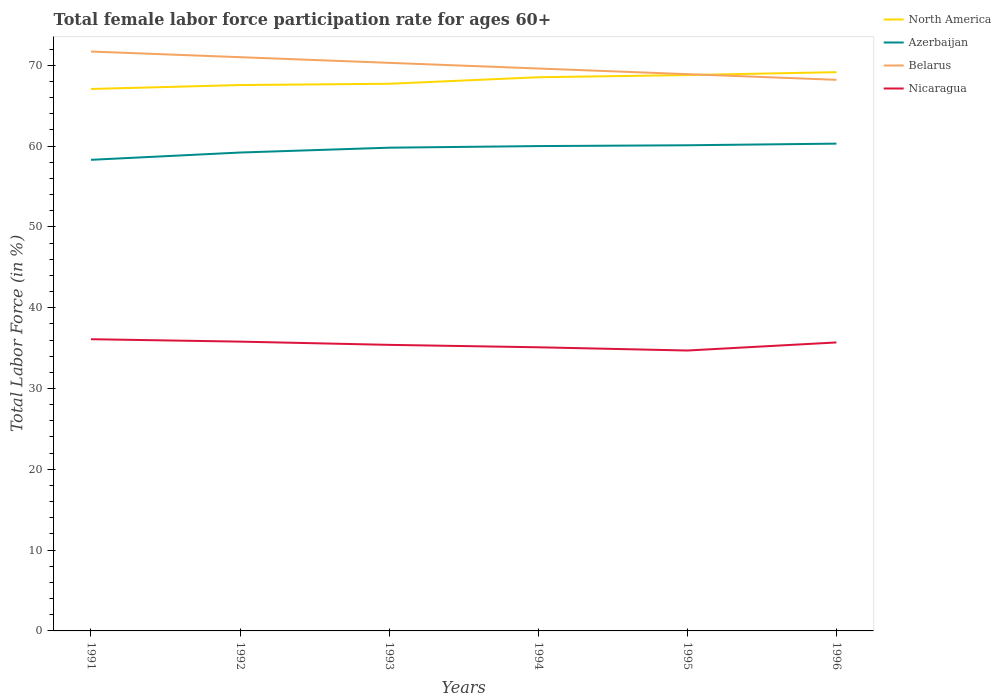How many different coloured lines are there?
Make the answer very short. 4. Does the line corresponding to North America intersect with the line corresponding to Azerbaijan?
Provide a short and direct response. No. Is the number of lines equal to the number of legend labels?
Keep it short and to the point. Yes. Across all years, what is the maximum female labor force participation rate in North America?
Keep it short and to the point. 67.06. In which year was the female labor force participation rate in North America maximum?
Your answer should be compact. 1991. What is the total female labor force participation rate in Belarus in the graph?
Your answer should be compact. 0.7. What is the difference between the highest and the second highest female labor force participation rate in Nicaragua?
Provide a short and direct response. 1.4. What is the difference between the highest and the lowest female labor force participation rate in Azerbaijan?
Your answer should be very brief. 4. How many years are there in the graph?
Give a very brief answer. 6. What is the difference between two consecutive major ticks on the Y-axis?
Provide a succinct answer. 10. Are the values on the major ticks of Y-axis written in scientific E-notation?
Offer a very short reply. No. Does the graph contain grids?
Give a very brief answer. No. What is the title of the graph?
Ensure brevity in your answer.  Total female labor force participation rate for ages 60+. What is the label or title of the X-axis?
Your answer should be compact. Years. What is the Total Labor Force (in %) in North America in 1991?
Provide a succinct answer. 67.06. What is the Total Labor Force (in %) in Azerbaijan in 1991?
Your answer should be very brief. 58.3. What is the Total Labor Force (in %) in Belarus in 1991?
Offer a very short reply. 71.7. What is the Total Labor Force (in %) in Nicaragua in 1991?
Offer a very short reply. 36.1. What is the Total Labor Force (in %) of North America in 1992?
Your answer should be compact. 67.55. What is the Total Labor Force (in %) of Azerbaijan in 1992?
Offer a very short reply. 59.2. What is the Total Labor Force (in %) in Belarus in 1992?
Offer a very short reply. 71. What is the Total Labor Force (in %) in Nicaragua in 1992?
Offer a terse response. 35.8. What is the Total Labor Force (in %) in North America in 1993?
Provide a short and direct response. 67.71. What is the Total Labor Force (in %) in Azerbaijan in 1993?
Ensure brevity in your answer.  59.8. What is the Total Labor Force (in %) of Belarus in 1993?
Provide a short and direct response. 70.3. What is the Total Labor Force (in %) in Nicaragua in 1993?
Provide a short and direct response. 35.4. What is the Total Labor Force (in %) of North America in 1994?
Keep it short and to the point. 68.52. What is the Total Labor Force (in %) of Belarus in 1994?
Provide a short and direct response. 69.6. What is the Total Labor Force (in %) of Nicaragua in 1994?
Provide a short and direct response. 35.1. What is the Total Labor Force (in %) of North America in 1995?
Provide a short and direct response. 68.79. What is the Total Labor Force (in %) of Azerbaijan in 1995?
Provide a short and direct response. 60.1. What is the Total Labor Force (in %) in Belarus in 1995?
Offer a terse response. 68.9. What is the Total Labor Force (in %) of Nicaragua in 1995?
Provide a succinct answer. 34.7. What is the Total Labor Force (in %) in North America in 1996?
Make the answer very short. 69.15. What is the Total Labor Force (in %) of Azerbaijan in 1996?
Make the answer very short. 60.3. What is the Total Labor Force (in %) of Belarus in 1996?
Offer a very short reply. 68.2. What is the Total Labor Force (in %) of Nicaragua in 1996?
Offer a terse response. 35.7. Across all years, what is the maximum Total Labor Force (in %) in North America?
Offer a terse response. 69.15. Across all years, what is the maximum Total Labor Force (in %) of Azerbaijan?
Your response must be concise. 60.3. Across all years, what is the maximum Total Labor Force (in %) in Belarus?
Keep it short and to the point. 71.7. Across all years, what is the maximum Total Labor Force (in %) in Nicaragua?
Your response must be concise. 36.1. Across all years, what is the minimum Total Labor Force (in %) of North America?
Your answer should be very brief. 67.06. Across all years, what is the minimum Total Labor Force (in %) in Azerbaijan?
Provide a short and direct response. 58.3. Across all years, what is the minimum Total Labor Force (in %) in Belarus?
Provide a succinct answer. 68.2. Across all years, what is the minimum Total Labor Force (in %) in Nicaragua?
Your response must be concise. 34.7. What is the total Total Labor Force (in %) in North America in the graph?
Your answer should be compact. 408.78. What is the total Total Labor Force (in %) of Azerbaijan in the graph?
Ensure brevity in your answer.  357.7. What is the total Total Labor Force (in %) of Belarus in the graph?
Provide a succinct answer. 419.7. What is the total Total Labor Force (in %) in Nicaragua in the graph?
Offer a very short reply. 212.8. What is the difference between the Total Labor Force (in %) of North America in 1991 and that in 1992?
Ensure brevity in your answer.  -0.49. What is the difference between the Total Labor Force (in %) in Belarus in 1991 and that in 1992?
Give a very brief answer. 0.7. What is the difference between the Total Labor Force (in %) of Nicaragua in 1991 and that in 1992?
Ensure brevity in your answer.  0.3. What is the difference between the Total Labor Force (in %) in North America in 1991 and that in 1993?
Give a very brief answer. -0.65. What is the difference between the Total Labor Force (in %) of Azerbaijan in 1991 and that in 1993?
Ensure brevity in your answer.  -1.5. What is the difference between the Total Labor Force (in %) in Belarus in 1991 and that in 1993?
Keep it short and to the point. 1.4. What is the difference between the Total Labor Force (in %) in Nicaragua in 1991 and that in 1993?
Your answer should be compact. 0.7. What is the difference between the Total Labor Force (in %) in North America in 1991 and that in 1994?
Your answer should be compact. -1.45. What is the difference between the Total Labor Force (in %) in North America in 1991 and that in 1995?
Provide a short and direct response. -1.72. What is the difference between the Total Labor Force (in %) of Belarus in 1991 and that in 1995?
Give a very brief answer. 2.8. What is the difference between the Total Labor Force (in %) in Nicaragua in 1991 and that in 1995?
Ensure brevity in your answer.  1.4. What is the difference between the Total Labor Force (in %) in North America in 1991 and that in 1996?
Make the answer very short. -2.08. What is the difference between the Total Labor Force (in %) of Azerbaijan in 1991 and that in 1996?
Keep it short and to the point. -2. What is the difference between the Total Labor Force (in %) in Belarus in 1991 and that in 1996?
Your answer should be very brief. 3.5. What is the difference between the Total Labor Force (in %) of Nicaragua in 1991 and that in 1996?
Provide a short and direct response. 0.4. What is the difference between the Total Labor Force (in %) of North America in 1992 and that in 1993?
Ensure brevity in your answer.  -0.16. What is the difference between the Total Labor Force (in %) of Azerbaijan in 1992 and that in 1993?
Give a very brief answer. -0.6. What is the difference between the Total Labor Force (in %) of Belarus in 1992 and that in 1993?
Give a very brief answer. 0.7. What is the difference between the Total Labor Force (in %) of North America in 1992 and that in 1994?
Give a very brief answer. -0.97. What is the difference between the Total Labor Force (in %) in Belarus in 1992 and that in 1994?
Provide a succinct answer. 1.4. What is the difference between the Total Labor Force (in %) in North America in 1992 and that in 1995?
Provide a succinct answer. -1.24. What is the difference between the Total Labor Force (in %) of Nicaragua in 1992 and that in 1995?
Keep it short and to the point. 1.1. What is the difference between the Total Labor Force (in %) in North America in 1992 and that in 1996?
Keep it short and to the point. -1.6. What is the difference between the Total Labor Force (in %) of North America in 1993 and that in 1994?
Offer a terse response. -0.81. What is the difference between the Total Labor Force (in %) of North America in 1993 and that in 1995?
Provide a succinct answer. -1.08. What is the difference between the Total Labor Force (in %) of Belarus in 1993 and that in 1995?
Provide a short and direct response. 1.4. What is the difference between the Total Labor Force (in %) in North America in 1993 and that in 1996?
Your response must be concise. -1.44. What is the difference between the Total Labor Force (in %) of Azerbaijan in 1993 and that in 1996?
Provide a short and direct response. -0.5. What is the difference between the Total Labor Force (in %) in North America in 1994 and that in 1995?
Make the answer very short. -0.27. What is the difference between the Total Labor Force (in %) in Azerbaijan in 1994 and that in 1995?
Your response must be concise. -0.1. What is the difference between the Total Labor Force (in %) in Nicaragua in 1994 and that in 1995?
Your answer should be compact. 0.4. What is the difference between the Total Labor Force (in %) of North America in 1994 and that in 1996?
Ensure brevity in your answer.  -0.63. What is the difference between the Total Labor Force (in %) of Belarus in 1994 and that in 1996?
Provide a short and direct response. 1.4. What is the difference between the Total Labor Force (in %) in North America in 1995 and that in 1996?
Your answer should be very brief. -0.36. What is the difference between the Total Labor Force (in %) in Nicaragua in 1995 and that in 1996?
Your response must be concise. -1. What is the difference between the Total Labor Force (in %) in North America in 1991 and the Total Labor Force (in %) in Azerbaijan in 1992?
Your response must be concise. 7.86. What is the difference between the Total Labor Force (in %) in North America in 1991 and the Total Labor Force (in %) in Belarus in 1992?
Your response must be concise. -3.94. What is the difference between the Total Labor Force (in %) of North America in 1991 and the Total Labor Force (in %) of Nicaragua in 1992?
Make the answer very short. 31.26. What is the difference between the Total Labor Force (in %) of Azerbaijan in 1991 and the Total Labor Force (in %) of Belarus in 1992?
Provide a short and direct response. -12.7. What is the difference between the Total Labor Force (in %) of Belarus in 1991 and the Total Labor Force (in %) of Nicaragua in 1992?
Make the answer very short. 35.9. What is the difference between the Total Labor Force (in %) in North America in 1991 and the Total Labor Force (in %) in Azerbaijan in 1993?
Provide a short and direct response. 7.26. What is the difference between the Total Labor Force (in %) of North America in 1991 and the Total Labor Force (in %) of Belarus in 1993?
Give a very brief answer. -3.24. What is the difference between the Total Labor Force (in %) in North America in 1991 and the Total Labor Force (in %) in Nicaragua in 1993?
Your response must be concise. 31.66. What is the difference between the Total Labor Force (in %) in Azerbaijan in 1991 and the Total Labor Force (in %) in Nicaragua in 1993?
Your response must be concise. 22.9. What is the difference between the Total Labor Force (in %) in Belarus in 1991 and the Total Labor Force (in %) in Nicaragua in 1993?
Give a very brief answer. 36.3. What is the difference between the Total Labor Force (in %) of North America in 1991 and the Total Labor Force (in %) of Azerbaijan in 1994?
Your response must be concise. 7.06. What is the difference between the Total Labor Force (in %) in North America in 1991 and the Total Labor Force (in %) in Belarus in 1994?
Offer a very short reply. -2.54. What is the difference between the Total Labor Force (in %) in North America in 1991 and the Total Labor Force (in %) in Nicaragua in 1994?
Offer a terse response. 31.96. What is the difference between the Total Labor Force (in %) of Azerbaijan in 1991 and the Total Labor Force (in %) of Belarus in 1994?
Make the answer very short. -11.3. What is the difference between the Total Labor Force (in %) of Azerbaijan in 1991 and the Total Labor Force (in %) of Nicaragua in 1994?
Make the answer very short. 23.2. What is the difference between the Total Labor Force (in %) of Belarus in 1991 and the Total Labor Force (in %) of Nicaragua in 1994?
Offer a very short reply. 36.6. What is the difference between the Total Labor Force (in %) of North America in 1991 and the Total Labor Force (in %) of Azerbaijan in 1995?
Offer a terse response. 6.96. What is the difference between the Total Labor Force (in %) of North America in 1991 and the Total Labor Force (in %) of Belarus in 1995?
Keep it short and to the point. -1.84. What is the difference between the Total Labor Force (in %) in North America in 1991 and the Total Labor Force (in %) in Nicaragua in 1995?
Give a very brief answer. 32.36. What is the difference between the Total Labor Force (in %) of Azerbaijan in 1991 and the Total Labor Force (in %) of Belarus in 1995?
Provide a short and direct response. -10.6. What is the difference between the Total Labor Force (in %) in Azerbaijan in 1991 and the Total Labor Force (in %) in Nicaragua in 1995?
Your answer should be compact. 23.6. What is the difference between the Total Labor Force (in %) in Belarus in 1991 and the Total Labor Force (in %) in Nicaragua in 1995?
Your response must be concise. 37. What is the difference between the Total Labor Force (in %) in North America in 1991 and the Total Labor Force (in %) in Azerbaijan in 1996?
Give a very brief answer. 6.76. What is the difference between the Total Labor Force (in %) in North America in 1991 and the Total Labor Force (in %) in Belarus in 1996?
Offer a very short reply. -1.14. What is the difference between the Total Labor Force (in %) in North America in 1991 and the Total Labor Force (in %) in Nicaragua in 1996?
Your answer should be very brief. 31.36. What is the difference between the Total Labor Force (in %) of Azerbaijan in 1991 and the Total Labor Force (in %) of Nicaragua in 1996?
Keep it short and to the point. 22.6. What is the difference between the Total Labor Force (in %) in Belarus in 1991 and the Total Labor Force (in %) in Nicaragua in 1996?
Offer a terse response. 36. What is the difference between the Total Labor Force (in %) in North America in 1992 and the Total Labor Force (in %) in Azerbaijan in 1993?
Your answer should be very brief. 7.75. What is the difference between the Total Labor Force (in %) in North America in 1992 and the Total Labor Force (in %) in Belarus in 1993?
Offer a very short reply. -2.75. What is the difference between the Total Labor Force (in %) of North America in 1992 and the Total Labor Force (in %) of Nicaragua in 1993?
Offer a very short reply. 32.15. What is the difference between the Total Labor Force (in %) in Azerbaijan in 1992 and the Total Labor Force (in %) in Belarus in 1993?
Provide a succinct answer. -11.1. What is the difference between the Total Labor Force (in %) of Azerbaijan in 1992 and the Total Labor Force (in %) of Nicaragua in 1993?
Offer a very short reply. 23.8. What is the difference between the Total Labor Force (in %) of Belarus in 1992 and the Total Labor Force (in %) of Nicaragua in 1993?
Offer a terse response. 35.6. What is the difference between the Total Labor Force (in %) of North America in 1992 and the Total Labor Force (in %) of Azerbaijan in 1994?
Your response must be concise. 7.55. What is the difference between the Total Labor Force (in %) in North America in 1992 and the Total Labor Force (in %) in Belarus in 1994?
Make the answer very short. -2.05. What is the difference between the Total Labor Force (in %) in North America in 1992 and the Total Labor Force (in %) in Nicaragua in 1994?
Provide a succinct answer. 32.45. What is the difference between the Total Labor Force (in %) of Azerbaijan in 1992 and the Total Labor Force (in %) of Nicaragua in 1994?
Give a very brief answer. 24.1. What is the difference between the Total Labor Force (in %) in Belarus in 1992 and the Total Labor Force (in %) in Nicaragua in 1994?
Your answer should be compact. 35.9. What is the difference between the Total Labor Force (in %) of North America in 1992 and the Total Labor Force (in %) of Azerbaijan in 1995?
Keep it short and to the point. 7.45. What is the difference between the Total Labor Force (in %) of North America in 1992 and the Total Labor Force (in %) of Belarus in 1995?
Provide a succinct answer. -1.35. What is the difference between the Total Labor Force (in %) in North America in 1992 and the Total Labor Force (in %) in Nicaragua in 1995?
Your response must be concise. 32.85. What is the difference between the Total Labor Force (in %) in Belarus in 1992 and the Total Labor Force (in %) in Nicaragua in 1995?
Give a very brief answer. 36.3. What is the difference between the Total Labor Force (in %) in North America in 1992 and the Total Labor Force (in %) in Azerbaijan in 1996?
Offer a terse response. 7.25. What is the difference between the Total Labor Force (in %) of North America in 1992 and the Total Labor Force (in %) of Belarus in 1996?
Offer a terse response. -0.65. What is the difference between the Total Labor Force (in %) in North America in 1992 and the Total Labor Force (in %) in Nicaragua in 1996?
Offer a terse response. 31.85. What is the difference between the Total Labor Force (in %) in Azerbaijan in 1992 and the Total Labor Force (in %) in Nicaragua in 1996?
Make the answer very short. 23.5. What is the difference between the Total Labor Force (in %) in Belarus in 1992 and the Total Labor Force (in %) in Nicaragua in 1996?
Offer a terse response. 35.3. What is the difference between the Total Labor Force (in %) in North America in 1993 and the Total Labor Force (in %) in Azerbaijan in 1994?
Ensure brevity in your answer.  7.71. What is the difference between the Total Labor Force (in %) of North America in 1993 and the Total Labor Force (in %) of Belarus in 1994?
Provide a succinct answer. -1.89. What is the difference between the Total Labor Force (in %) of North America in 1993 and the Total Labor Force (in %) of Nicaragua in 1994?
Offer a very short reply. 32.61. What is the difference between the Total Labor Force (in %) in Azerbaijan in 1993 and the Total Labor Force (in %) in Belarus in 1994?
Your answer should be compact. -9.8. What is the difference between the Total Labor Force (in %) of Azerbaijan in 1993 and the Total Labor Force (in %) of Nicaragua in 1994?
Your answer should be very brief. 24.7. What is the difference between the Total Labor Force (in %) of Belarus in 1993 and the Total Labor Force (in %) of Nicaragua in 1994?
Keep it short and to the point. 35.2. What is the difference between the Total Labor Force (in %) in North America in 1993 and the Total Labor Force (in %) in Azerbaijan in 1995?
Offer a very short reply. 7.61. What is the difference between the Total Labor Force (in %) of North America in 1993 and the Total Labor Force (in %) of Belarus in 1995?
Give a very brief answer. -1.19. What is the difference between the Total Labor Force (in %) in North America in 1993 and the Total Labor Force (in %) in Nicaragua in 1995?
Offer a terse response. 33.01. What is the difference between the Total Labor Force (in %) in Azerbaijan in 1993 and the Total Labor Force (in %) in Nicaragua in 1995?
Your answer should be compact. 25.1. What is the difference between the Total Labor Force (in %) of Belarus in 1993 and the Total Labor Force (in %) of Nicaragua in 1995?
Your answer should be compact. 35.6. What is the difference between the Total Labor Force (in %) in North America in 1993 and the Total Labor Force (in %) in Azerbaijan in 1996?
Give a very brief answer. 7.41. What is the difference between the Total Labor Force (in %) in North America in 1993 and the Total Labor Force (in %) in Belarus in 1996?
Keep it short and to the point. -0.49. What is the difference between the Total Labor Force (in %) of North America in 1993 and the Total Labor Force (in %) of Nicaragua in 1996?
Give a very brief answer. 32.01. What is the difference between the Total Labor Force (in %) of Azerbaijan in 1993 and the Total Labor Force (in %) of Nicaragua in 1996?
Make the answer very short. 24.1. What is the difference between the Total Labor Force (in %) in Belarus in 1993 and the Total Labor Force (in %) in Nicaragua in 1996?
Provide a succinct answer. 34.6. What is the difference between the Total Labor Force (in %) of North America in 1994 and the Total Labor Force (in %) of Azerbaijan in 1995?
Make the answer very short. 8.42. What is the difference between the Total Labor Force (in %) of North America in 1994 and the Total Labor Force (in %) of Belarus in 1995?
Provide a succinct answer. -0.38. What is the difference between the Total Labor Force (in %) in North America in 1994 and the Total Labor Force (in %) in Nicaragua in 1995?
Offer a terse response. 33.82. What is the difference between the Total Labor Force (in %) in Azerbaijan in 1994 and the Total Labor Force (in %) in Nicaragua in 1995?
Ensure brevity in your answer.  25.3. What is the difference between the Total Labor Force (in %) of Belarus in 1994 and the Total Labor Force (in %) of Nicaragua in 1995?
Provide a succinct answer. 34.9. What is the difference between the Total Labor Force (in %) of North America in 1994 and the Total Labor Force (in %) of Azerbaijan in 1996?
Offer a very short reply. 8.22. What is the difference between the Total Labor Force (in %) in North America in 1994 and the Total Labor Force (in %) in Belarus in 1996?
Keep it short and to the point. 0.32. What is the difference between the Total Labor Force (in %) in North America in 1994 and the Total Labor Force (in %) in Nicaragua in 1996?
Make the answer very short. 32.82. What is the difference between the Total Labor Force (in %) in Azerbaijan in 1994 and the Total Labor Force (in %) in Nicaragua in 1996?
Your response must be concise. 24.3. What is the difference between the Total Labor Force (in %) in Belarus in 1994 and the Total Labor Force (in %) in Nicaragua in 1996?
Make the answer very short. 33.9. What is the difference between the Total Labor Force (in %) of North America in 1995 and the Total Labor Force (in %) of Azerbaijan in 1996?
Your answer should be compact. 8.49. What is the difference between the Total Labor Force (in %) in North America in 1995 and the Total Labor Force (in %) in Belarus in 1996?
Your answer should be very brief. 0.59. What is the difference between the Total Labor Force (in %) of North America in 1995 and the Total Labor Force (in %) of Nicaragua in 1996?
Provide a succinct answer. 33.09. What is the difference between the Total Labor Force (in %) in Azerbaijan in 1995 and the Total Labor Force (in %) in Belarus in 1996?
Offer a terse response. -8.1. What is the difference between the Total Labor Force (in %) in Azerbaijan in 1995 and the Total Labor Force (in %) in Nicaragua in 1996?
Provide a short and direct response. 24.4. What is the difference between the Total Labor Force (in %) in Belarus in 1995 and the Total Labor Force (in %) in Nicaragua in 1996?
Give a very brief answer. 33.2. What is the average Total Labor Force (in %) in North America per year?
Your response must be concise. 68.13. What is the average Total Labor Force (in %) of Azerbaijan per year?
Your response must be concise. 59.62. What is the average Total Labor Force (in %) in Belarus per year?
Give a very brief answer. 69.95. What is the average Total Labor Force (in %) of Nicaragua per year?
Keep it short and to the point. 35.47. In the year 1991, what is the difference between the Total Labor Force (in %) of North America and Total Labor Force (in %) of Azerbaijan?
Offer a very short reply. 8.76. In the year 1991, what is the difference between the Total Labor Force (in %) in North America and Total Labor Force (in %) in Belarus?
Make the answer very short. -4.64. In the year 1991, what is the difference between the Total Labor Force (in %) of North America and Total Labor Force (in %) of Nicaragua?
Your answer should be compact. 30.96. In the year 1991, what is the difference between the Total Labor Force (in %) in Azerbaijan and Total Labor Force (in %) in Nicaragua?
Ensure brevity in your answer.  22.2. In the year 1991, what is the difference between the Total Labor Force (in %) in Belarus and Total Labor Force (in %) in Nicaragua?
Make the answer very short. 35.6. In the year 1992, what is the difference between the Total Labor Force (in %) in North America and Total Labor Force (in %) in Azerbaijan?
Provide a short and direct response. 8.35. In the year 1992, what is the difference between the Total Labor Force (in %) in North America and Total Labor Force (in %) in Belarus?
Ensure brevity in your answer.  -3.45. In the year 1992, what is the difference between the Total Labor Force (in %) of North America and Total Labor Force (in %) of Nicaragua?
Your response must be concise. 31.75. In the year 1992, what is the difference between the Total Labor Force (in %) in Azerbaijan and Total Labor Force (in %) in Nicaragua?
Your answer should be very brief. 23.4. In the year 1992, what is the difference between the Total Labor Force (in %) of Belarus and Total Labor Force (in %) of Nicaragua?
Give a very brief answer. 35.2. In the year 1993, what is the difference between the Total Labor Force (in %) in North America and Total Labor Force (in %) in Azerbaijan?
Give a very brief answer. 7.91. In the year 1993, what is the difference between the Total Labor Force (in %) of North America and Total Labor Force (in %) of Belarus?
Your response must be concise. -2.59. In the year 1993, what is the difference between the Total Labor Force (in %) in North America and Total Labor Force (in %) in Nicaragua?
Your response must be concise. 32.31. In the year 1993, what is the difference between the Total Labor Force (in %) in Azerbaijan and Total Labor Force (in %) in Belarus?
Your answer should be compact. -10.5. In the year 1993, what is the difference between the Total Labor Force (in %) in Azerbaijan and Total Labor Force (in %) in Nicaragua?
Provide a short and direct response. 24.4. In the year 1993, what is the difference between the Total Labor Force (in %) in Belarus and Total Labor Force (in %) in Nicaragua?
Give a very brief answer. 34.9. In the year 1994, what is the difference between the Total Labor Force (in %) in North America and Total Labor Force (in %) in Azerbaijan?
Your answer should be very brief. 8.52. In the year 1994, what is the difference between the Total Labor Force (in %) in North America and Total Labor Force (in %) in Belarus?
Keep it short and to the point. -1.08. In the year 1994, what is the difference between the Total Labor Force (in %) in North America and Total Labor Force (in %) in Nicaragua?
Ensure brevity in your answer.  33.42. In the year 1994, what is the difference between the Total Labor Force (in %) in Azerbaijan and Total Labor Force (in %) in Nicaragua?
Your answer should be very brief. 24.9. In the year 1994, what is the difference between the Total Labor Force (in %) of Belarus and Total Labor Force (in %) of Nicaragua?
Give a very brief answer. 34.5. In the year 1995, what is the difference between the Total Labor Force (in %) of North America and Total Labor Force (in %) of Azerbaijan?
Provide a succinct answer. 8.69. In the year 1995, what is the difference between the Total Labor Force (in %) of North America and Total Labor Force (in %) of Belarus?
Offer a terse response. -0.11. In the year 1995, what is the difference between the Total Labor Force (in %) in North America and Total Labor Force (in %) in Nicaragua?
Make the answer very short. 34.09. In the year 1995, what is the difference between the Total Labor Force (in %) of Azerbaijan and Total Labor Force (in %) of Nicaragua?
Offer a terse response. 25.4. In the year 1995, what is the difference between the Total Labor Force (in %) in Belarus and Total Labor Force (in %) in Nicaragua?
Your answer should be very brief. 34.2. In the year 1996, what is the difference between the Total Labor Force (in %) of North America and Total Labor Force (in %) of Azerbaijan?
Offer a very short reply. 8.85. In the year 1996, what is the difference between the Total Labor Force (in %) in North America and Total Labor Force (in %) in Belarus?
Make the answer very short. 0.95. In the year 1996, what is the difference between the Total Labor Force (in %) in North America and Total Labor Force (in %) in Nicaragua?
Provide a succinct answer. 33.45. In the year 1996, what is the difference between the Total Labor Force (in %) of Azerbaijan and Total Labor Force (in %) of Nicaragua?
Offer a terse response. 24.6. In the year 1996, what is the difference between the Total Labor Force (in %) in Belarus and Total Labor Force (in %) in Nicaragua?
Offer a terse response. 32.5. What is the ratio of the Total Labor Force (in %) in Belarus in 1991 to that in 1992?
Your response must be concise. 1.01. What is the ratio of the Total Labor Force (in %) in Nicaragua in 1991 to that in 1992?
Make the answer very short. 1.01. What is the ratio of the Total Labor Force (in %) in Azerbaijan in 1991 to that in 1993?
Make the answer very short. 0.97. What is the ratio of the Total Labor Force (in %) in Belarus in 1991 to that in 1993?
Your answer should be very brief. 1.02. What is the ratio of the Total Labor Force (in %) of Nicaragua in 1991 to that in 1993?
Your answer should be very brief. 1.02. What is the ratio of the Total Labor Force (in %) of North America in 1991 to that in 1994?
Keep it short and to the point. 0.98. What is the ratio of the Total Labor Force (in %) of Azerbaijan in 1991 to that in 1994?
Keep it short and to the point. 0.97. What is the ratio of the Total Labor Force (in %) in Belarus in 1991 to that in 1994?
Keep it short and to the point. 1.03. What is the ratio of the Total Labor Force (in %) of Nicaragua in 1991 to that in 1994?
Give a very brief answer. 1.03. What is the ratio of the Total Labor Force (in %) of North America in 1991 to that in 1995?
Your answer should be very brief. 0.97. What is the ratio of the Total Labor Force (in %) of Azerbaijan in 1991 to that in 1995?
Make the answer very short. 0.97. What is the ratio of the Total Labor Force (in %) of Belarus in 1991 to that in 1995?
Keep it short and to the point. 1.04. What is the ratio of the Total Labor Force (in %) of Nicaragua in 1991 to that in 1995?
Provide a succinct answer. 1.04. What is the ratio of the Total Labor Force (in %) of North America in 1991 to that in 1996?
Offer a very short reply. 0.97. What is the ratio of the Total Labor Force (in %) in Azerbaijan in 1991 to that in 1996?
Offer a very short reply. 0.97. What is the ratio of the Total Labor Force (in %) in Belarus in 1991 to that in 1996?
Provide a succinct answer. 1.05. What is the ratio of the Total Labor Force (in %) in Nicaragua in 1991 to that in 1996?
Make the answer very short. 1.01. What is the ratio of the Total Labor Force (in %) in Azerbaijan in 1992 to that in 1993?
Provide a short and direct response. 0.99. What is the ratio of the Total Labor Force (in %) of Nicaragua in 1992 to that in 1993?
Make the answer very short. 1.01. What is the ratio of the Total Labor Force (in %) in North America in 1992 to that in 1994?
Make the answer very short. 0.99. What is the ratio of the Total Labor Force (in %) in Azerbaijan in 1992 to that in 1994?
Give a very brief answer. 0.99. What is the ratio of the Total Labor Force (in %) of Belarus in 1992 to that in 1994?
Offer a terse response. 1.02. What is the ratio of the Total Labor Force (in %) in Nicaragua in 1992 to that in 1994?
Give a very brief answer. 1.02. What is the ratio of the Total Labor Force (in %) in North America in 1992 to that in 1995?
Your answer should be very brief. 0.98. What is the ratio of the Total Labor Force (in %) of Belarus in 1992 to that in 1995?
Provide a succinct answer. 1.03. What is the ratio of the Total Labor Force (in %) of Nicaragua in 1992 to that in 1995?
Your response must be concise. 1.03. What is the ratio of the Total Labor Force (in %) in North America in 1992 to that in 1996?
Ensure brevity in your answer.  0.98. What is the ratio of the Total Labor Force (in %) of Azerbaijan in 1992 to that in 1996?
Provide a succinct answer. 0.98. What is the ratio of the Total Labor Force (in %) of Belarus in 1992 to that in 1996?
Offer a terse response. 1.04. What is the ratio of the Total Labor Force (in %) of Nicaragua in 1992 to that in 1996?
Provide a succinct answer. 1. What is the ratio of the Total Labor Force (in %) of Azerbaijan in 1993 to that in 1994?
Your answer should be compact. 1. What is the ratio of the Total Labor Force (in %) of Nicaragua in 1993 to that in 1994?
Provide a succinct answer. 1.01. What is the ratio of the Total Labor Force (in %) of North America in 1993 to that in 1995?
Make the answer very short. 0.98. What is the ratio of the Total Labor Force (in %) of Azerbaijan in 1993 to that in 1995?
Make the answer very short. 0.99. What is the ratio of the Total Labor Force (in %) in Belarus in 1993 to that in 1995?
Offer a terse response. 1.02. What is the ratio of the Total Labor Force (in %) in Nicaragua in 1993 to that in 1995?
Provide a short and direct response. 1.02. What is the ratio of the Total Labor Force (in %) in North America in 1993 to that in 1996?
Ensure brevity in your answer.  0.98. What is the ratio of the Total Labor Force (in %) in Azerbaijan in 1993 to that in 1996?
Provide a succinct answer. 0.99. What is the ratio of the Total Labor Force (in %) of Belarus in 1993 to that in 1996?
Give a very brief answer. 1.03. What is the ratio of the Total Labor Force (in %) of Nicaragua in 1993 to that in 1996?
Offer a terse response. 0.99. What is the ratio of the Total Labor Force (in %) in Azerbaijan in 1994 to that in 1995?
Provide a short and direct response. 1. What is the ratio of the Total Labor Force (in %) of Belarus in 1994 to that in 1995?
Provide a short and direct response. 1.01. What is the ratio of the Total Labor Force (in %) of Nicaragua in 1994 to that in 1995?
Provide a succinct answer. 1.01. What is the ratio of the Total Labor Force (in %) in North America in 1994 to that in 1996?
Make the answer very short. 0.99. What is the ratio of the Total Labor Force (in %) of Azerbaijan in 1994 to that in 1996?
Your answer should be very brief. 0.99. What is the ratio of the Total Labor Force (in %) of Belarus in 1994 to that in 1996?
Provide a succinct answer. 1.02. What is the ratio of the Total Labor Force (in %) in Nicaragua in 1994 to that in 1996?
Give a very brief answer. 0.98. What is the ratio of the Total Labor Force (in %) of Azerbaijan in 1995 to that in 1996?
Ensure brevity in your answer.  1. What is the ratio of the Total Labor Force (in %) of Belarus in 1995 to that in 1996?
Your answer should be very brief. 1.01. What is the difference between the highest and the second highest Total Labor Force (in %) in North America?
Provide a succinct answer. 0.36. What is the difference between the highest and the second highest Total Labor Force (in %) in Azerbaijan?
Ensure brevity in your answer.  0.2. What is the difference between the highest and the second highest Total Labor Force (in %) of Belarus?
Keep it short and to the point. 0.7. What is the difference between the highest and the lowest Total Labor Force (in %) in North America?
Make the answer very short. 2.08. What is the difference between the highest and the lowest Total Labor Force (in %) of Belarus?
Your answer should be very brief. 3.5. 